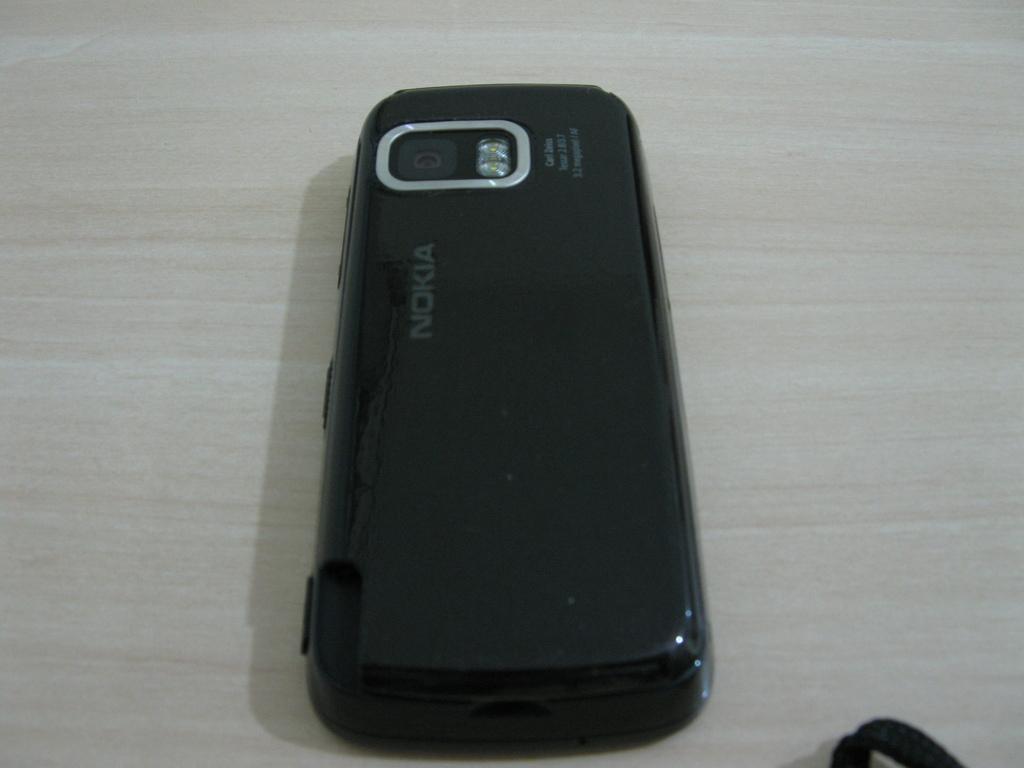What brand is this phone?
Provide a short and direct response. Nokia. 